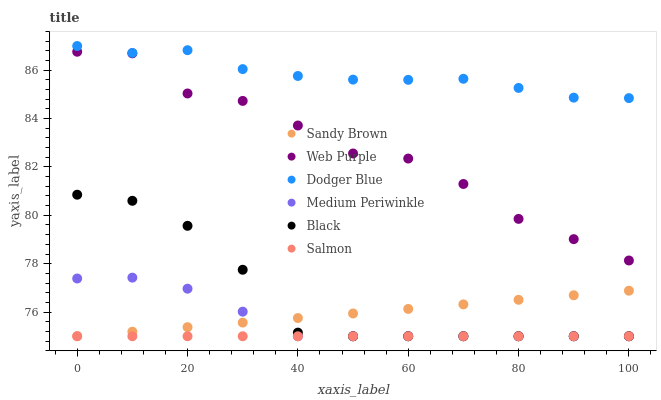Does Salmon have the minimum area under the curve?
Answer yes or no. Yes. Does Dodger Blue have the maximum area under the curve?
Answer yes or no. Yes. Does Web Purple have the minimum area under the curve?
Answer yes or no. No. Does Web Purple have the maximum area under the curve?
Answer yes or no. No. Is Sandy Brown the smoothest?
Answer yes or no. Yes. Is Web Purple the roughest?
Answer yes or no. Yes. Is Salmon the smoothest?
Answer yes or no. No. Is Salmon the roughest?
Answer yes or no. No. Does Medium Periwinkle have the lowest value?
Answer yes or no. Yes. Does Web Purple have the lowest value?
Answer yes or no. No. Does Dodger Blue have the highest value?
Answer yes or no. Yes. Does Web Purple have the highest value?
Answer yes or no. No. Is Web Purple less than Dodger Blue?
Answer yes or no. Yes. Is Dodger Blue greater than Black?
Answer yes or no. Yes. Does Black intersect Sandy Brown?
Answer yes or no. Yes. Is Black less than Sandy Brown?
Answer yes or no. No. Is Black greater than Sandy Brown?
Answer yes or no. No. Does Web Purple intersect Dodger Blue?
Answer yes or no. No. 